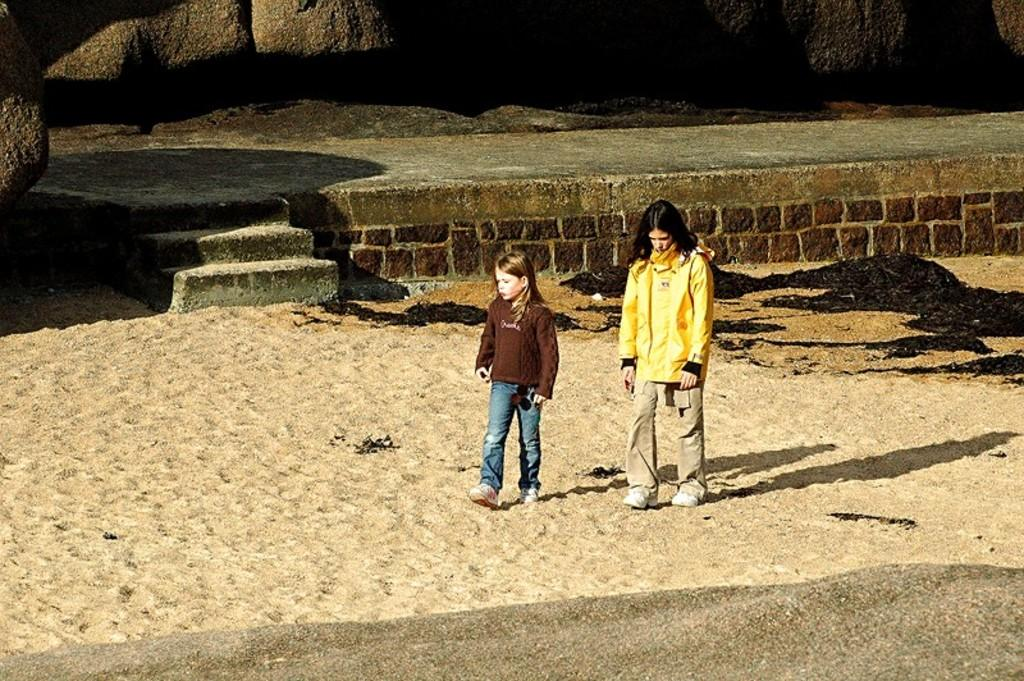How many people are in the image? There are two people standing on the sand. What is in the background of the image? There is a platform with a staircase and rocks visible in the background. What type of boot can be seen on the map in the image? There is no map or boot present in the image. 